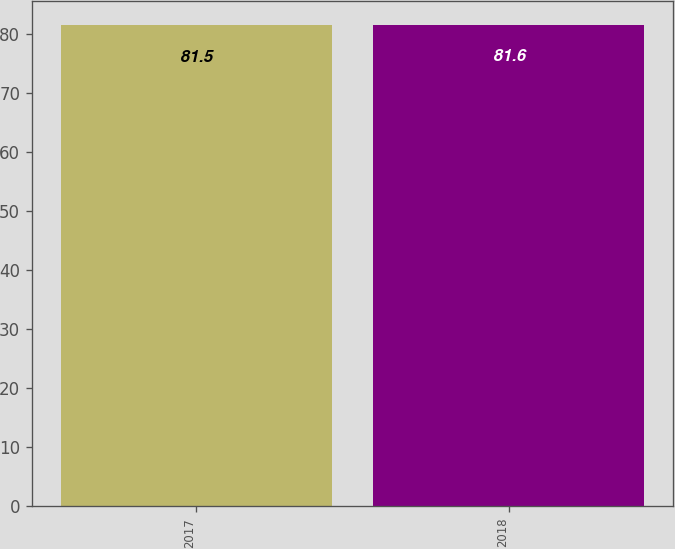<chart> <loc_0><loc_0><loc_500><loc_500><bar_chart><fcel>2017<fcel>2018<nl><fcel>81.5<fcel>81.6<nl></chart> 